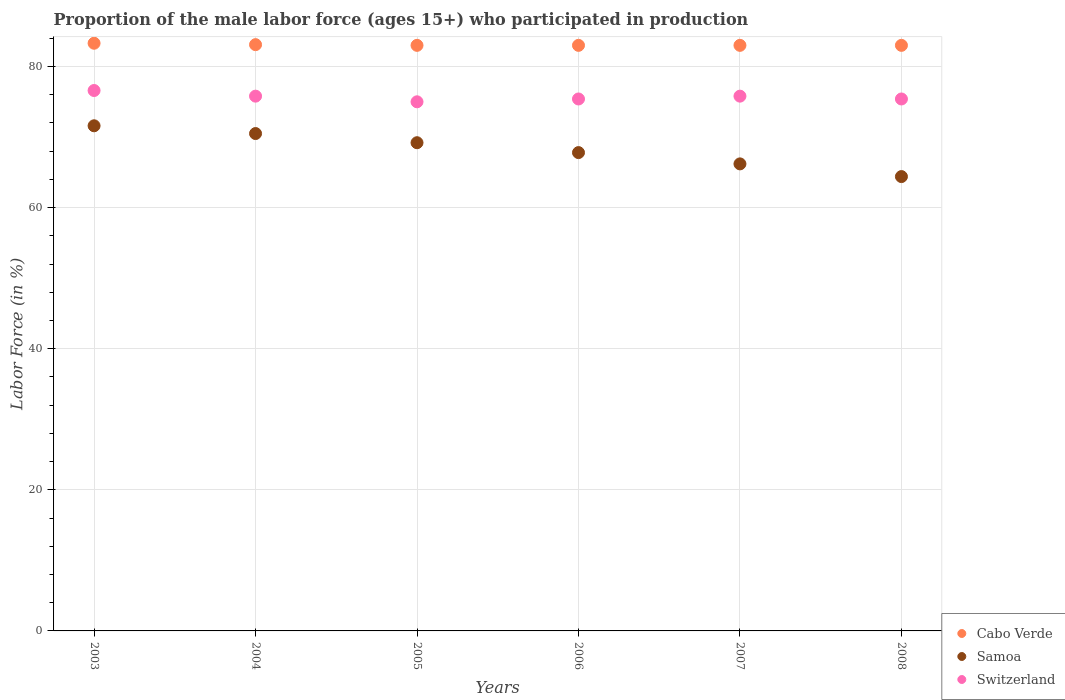How many different coloured dotlines are there?
Offer a terse response. 3. What is the proportion of the male labor force who participated in production in Samoa in 2004?
Your answer should be very brief. 70.5. Across all years, what is the maximum proportion of the male labor force who participated in production in Samoa?
Provide a short and direct response. 71.6. Across all years, what is the minimum proportion of the male labor force who participated in production in Samoa?
Keep it short and to the point. 64.4. In which year was the proportion of the male labor force who participated in production in Switzerland maximum?
Make the answer very short. 2003. In which year was the proportion of the male labor force who participated in production in Cabo Verde minimum?
Your answer should be compact. 2005. What is the total proportion of the male labor force who participated in production in Switzerland in the graph?
Provide a succinct answer. 454. What is the difference between the proportion of the male labor force who participated in production in Switzerland in 2004 and that in 2005?
Keep it short and to the point. 0.8. What is the difference between the proportion of the male labor force who participated in production in Cabo Verde in 2004 and the proportion of the male labor force who participated in production in Switzerland in 2007?
Provide a succinct answer. 7.3. What is the average proportion of the male labor force who participated in production in Samoa per year?
Give a very brief answer. 68.28. In the year 2004, what is the difference between the proportion of the male labor force who participated in production in Switzerland and proportion of the male labor force who participated in production in Cabo Verde?
Keep it short and to the point. -7.3. Is the difference between the proportion of the male labor force who participated in production in Switzerland in 2003 and 2006 greater than the difference between the proportion of the male labor force who participated in production in Cabo Verde in 2003 and 2006?
Make the answer very short. Yes. What is the difference between the highest and the second highest proportion of the male labor force who participated in production in Samoa?
Your answer should be very brief. 1.1. What is the difference between the highest and the lowest proportion of the male labor force who participated in production in Switzerland?
Keep it short and to the point. 1.6. Is the proportion of the male labor force who participated in production in Cabo Verde strictly greater than the proportion of the male labor force who participated in production in Samoa over the years?
Give a very brief answer. Yes. Is the proportion of the male labor force who participated in production in Switzerland strictly less than the proportion of the male labor force who participated in production in Cabo Verde over the years?
Provide a succinct answer. Yes. How many years are there in the graph?
Offer a terse response. 6. What is the difference between two consecutive major ticks on the Y-axis?
Offer a very short reply. 20. Does the graph contain any zero values?
Provide a succinct answer. No. Where does the legend appear in the graph?
Ensure brevity in your answer.  Bottom right. How many legend labels are there?
Give a very brief answer. 3. How are the legend labels stacked?
Give a very brief answer. Vertical. What is the title of the graph?
Offer a terse response. Proportion of the male labor force (ages 15+) who participated in production. Does "Palau" appear as one of the legend labels in the graph?
Make the answer very short. No. What is the label or title of the X-axis?
Make the answer very short. Years. What is the label or title of the Y-axis?
Give a very brief answer. Labor Force (in %). What is the Labor Force (in %) in Cabo Verde in 2003?
Your answer should be compact. 83.3. What is the Labor Force (in %) of Samoa in 2003?
Make the answer very short. 71.6. What is the Labor Force (in %) of Switzerland in 2003?
Make the answer very short. 76.6. What is the Labor Force (in %) in Cabo Verde in 2004?
Ensure brevity in your answer.  83.1. What is the Labor Force (in %) in Samoa in 2004?
Your answer should be compact. 70.5. What is the Labor Force (in %) in Switzerland in 2004?
Provide a succinct answer. 75.8. What is the Labor Force (in %) in Cabo Verde in 2005?
Provide a short and direct response. 83. What is the Labor Force (in %) of Samoa in 2005?
Your response must be concise. 69.2. What is the Labor Force (in %) of Samoa in 2006?
Your response must be concise. 67.8. What is the Labor Force (in %) in Switzerland in 2006?
Keep it short and to the point. 75.4. What is the Labor Force (in %) of Samoa in 2007?
Offer a terse response. 66.2. What is the Labor Force (in %) of Switzerland in 2007?
Offer a very short reply. 75.8. What is the Labor Force (in %) of Samoa in 2008?
Provide a succinct answer. 64.4. What is the Labor Force (in %) in Switzerland in 2008?
Give a very brief answer. 75.4. Across all years, what is the maximum Labor Force (in %) of Cabo Verde?
Your answer should be very brief. 83.3. Across all years, what is the maximum Labor Force (in %) of Samoa?
Make the answer very short. 71.6. Across all years, what is the maximum Labor Force (in %) of Switzerland?
Your response must be concise. 76.6. Across all years, what is the minimum Labor Force (in %) of Cabo Verde?
Your response must be concise. 83. Across all years, what is the minimum Labor Force (in %) of Samoa?
Give a very brief answer. 64.4. What is the total Labor Force (in %) of Cabo Verde in the graph?
Your answer should be compact. 498.4. What is the total Labor Force (in %) of Samoa in the graph?
Provide a succinct answer. 409.7. What is the total Labor Force (in %) in Switzerland in the graph?
Your answer should be very brief. 454. What is the difference between the Labor Force (in %) of Samoa in 2003 and that in 2004?
Make the answer very short. 1.1. What is the difference between the Labor Force (in %) of Switzerland in 2003 and that in 2004?
Your response must be concise. 0.8. What is the difference between the Labor Force (in %) of Cabo Verde in 2003 and that in 2006?
Offer a very short reply. 0.3. What is the difference between the Labor Force (in %) in Samoa in 2003 and that in 2006?
Your answer should be very brief. 3.8. What is the difference between the Labor Force (in %) in Switzerland in 2003 and that in 2007?
Your response must be concise. 0.8. What is the difference between the Labor Force (in %) in Cabo Verde in 2003 and that in 2008?
Provide a short and direct response. 0.3. What is the difference between the Labor Force (in %) of Switzerland in 2003 and that in 2008?
Provide a short and direct response. 1.2. What is the difference between the Labor Force (in %) in Cabo Verde in 2004 and that in 2005?
Your answer should be very brief. 0.1. What is the difference between the Labor Force (in %) of Samoa in 2004 and that in 2005?
Ensure brevity in your answer.  1.3. What is the difference between the Labor Force (in %) in Samoa in 2004 and that in 2006?
Give a very brief answer. 2.7. What is the difference between the Labor Force (in %) in Cabo Verde in 2004 and that in 2007?
Give a very brief answer. 0.1. What is the difference between the Labor Force (in %) in Switzerland in 2005 and that in 2006?
Give a very brief answer. -0.4. What is the difference between the Labor Force (in %) of Switzerland in 2005 and that in 2007?
Provide a short and direct response. -0.8. What is the difference between the Labor Force (in %) in Cabo Verde in 2005 and that in 2008?
Your answer should be compact. 0. What is the difference between the Labor Force (in %) of Samoa in 2005 and that in 2008?
Ensure brevity in your answer.  4.8. What is the difference between the Labor Force (in %) in Cabo Verde in 2006 and that in 2007?
Keep it short and to the point. 0. What is the difference between the Labor Force (in %) of Samoa in 2006 and that in 2007?
Provide a succinct answer. 1.6. What is the difference between the Labor Force (in %) of Switzerland in 2006 and that in 2007?
Ensure brevity in your answer.  -0.4. What is the difference between the Labor Force (in %) in Cabo Verde in 2006 and that in 2008?
Offer a terse response. 0. What is the difference between the Labor Force (in %) in Samoa in 2007 and that in 2008?
Your answer should be very brief. 1.8. What is the difference between the Labor Force (in %) in Switzerland in 2007 and that in 2008?
Offer a terse response. 0.4. What is the difference between the Labor Force (in %) of Cabo Verde in 2003 and the Labor Force (in %) of Samoa in 2004?
Keep it short and to the point. 12.8. What is the difference between the Labor Force (in %) of Cabo Verde in 2003 and the Labor Force (in %) of Switzerland in 2004?
Offer a terse response. 7.5. What is the difference between the Labor Force (in %) in Samoa in 2003 and the Labor Force (in %) in Switzerland in 2004?
Keep it short and to the point. -4.2. What is the difference between the Labor Force (in %) of Cabo Verde in 2003 and the Labor Force (in %) of Samoa in 2005?
Keep it short and to the point. 14.1. What is the difference between the Labor Force (in %) in Cabo Verde in 2003 and the Labor Force (in %) in Switzerland in 2005?
Ensure brevity in your answer.  8.3. What is the difference between the Labor Force (in %) of Cabo Verde in 2003 and the Labor Force (in %) of Samoa in 2006?
Your answer should be very brief. 15.5. What is the difference between the Labor Force (in %) of Cabo Verde in 2003 and the Labor Force (in %) of Samoa in 2007?
Offer a very short reply. 17.1. What is the difference between the Labor Force (in %) of Cabo Verde in 2003 and the Labor Force (in %) of Switzerland in 2008?
Your answer should be very brief. 7.9. What is the difference between the Labor Force (in %) of Cabo Verde in 2004 and the Labor Force (in %) of Samoa in 2005?
Ensure brevity in your answer.  13.9. What is the difference between the Labor Force (in %) in Cabo Verde in 2004 and the Labor Force (in %) in Switzerland in 2005?
Give a very brief answer. 8.1. What is the difference between the Labor Force (in %) of Cabo Verde in 2004 and the Labor Force (in %) of Samoa in 2006?
Your answer should be very brief. 15.3. What is the difference between the Labor Force (in %) in Cabo Verde in 2004 and the Labor Force (in %) in Switzerland in 2006?
Make the answer very short. 7.7. What is the difference between the Labor Force (in %) of Cabo Verde in 2004 and the Labor Force (in %) of Samoa in 2008?
Your answer should be compact. 18.7. What is the difference between the Labor Force (in %) in Cabo Verde in 2005 and the Labor Force (in %) in Switzerland in 2006?
Offer a terse response. 7.6. What is the difference between the Labor Force (in %) in Samoa in 2005 and the Labor Force (in %) in Switzerland in 2006?
Give a very brief answer. -6.2. What is the difference between the Labor Force (in %) of Cabo Verde in 2005 and the Labor Force (in %) of Samoa in 2007?
Provide a short and direct response. 16.8. What is the difference between the Labor Force (in %) in Cabo Verde in 2005 and the Labor Force (in %) in Switzerland in 2007?
Provide a short and direct response. 7.2. What is the difference between the Labor Force (in %) in Cabo Verde in 2005 and the Labor Force (in %) in Switzerland in 2008?
Your response must be concise. 7.6. What is the difference between the Labor Force (in %) of Samoa in 2005 and the Labor Force (in %) of Switzerland in 2008?
Provide a short and direct response. -6.2. What is the difference between the Labor Force (in %) in Cabo Verde in 2006 and the Labor Force (in %) in Samoa in 2007?
Make the answer very short. 16.8. What is the difference between the Labor Force (in %) of Cabo Verde in 2006 and the Labor Force (in %) of Switzerland in 2007?
Give a very brief answer. 7.2. What is the difference between the Labor Force (in %) in Cabo Verde in 2006 and the Labor Force (in %) in Samoa in 2008?
Ensure brevity in your answer.  18.6. What is the difference between the Labor Force (in %) in Samoa in 2006 and the Labor Force (in %) in Switzerland in 2008?
Offer a terse response. -7.6. What is the difference between the Labor Force (in %) in Cabo Verde in 2007 and the Labor Force (in %) in Samoa in 2008?
Make the answer very short. 18.6. What is the difference between the Labor Force (in %) in Cabo Verde in 2007 and the Labor Force (in %) in Switzerland in 2008?
Make the answer very short. 7.6. What is the average Labor Force (in %) in Cabo Verde per year?
Provide a succinct answer. 83.07. What is the average Labor Force (in %) in Samoa per year?
Your answer should be compact. 68.28. What is the average Labor Force (in %) of Switzerland per year?
Your answer should be compact. 75.67. In the year 2003, what is the difference between the Labor Force (in %) in Cabo Verde and Labor Force (in %) in Samoa?
Provide a short and direct response. 11.7. In the year 2003, what is the difference between the Labor Force (in %) in Cabo Verde and Labor Force (in %) in Switzerland?
Your response must be concise. 6.7. In the year 2004, what is the difference between the Labor Force (in %) of Cabo Verde and Labor Force (in %) of Samoa?
Offer a terse response. 12.6. In the year 2004, what is the difference between the Labor Force (in %) in Cabo Verde and Labor Force (in %) in Switzerland?
Your response must be concise. 7.3. In the year 2004, what is the difference between the Labor Force (in %) in Samoa and Labor Force (in %) in Switzerland?
Offer a very short reply. -5.3. In the year 2006, what is the difference between the Labor Force (in %) in Samoa and Labor Force (in %) in Switzerland?
Offer a very short reply. -7.6. In the year 2007, what is the difference between the Labor Force (in %) of Samoa and Labor Force (in %) of Switzerland?
Offer a terse response. -9.6. What is the ratio of the Labor Force (in %) of Samoa in 2003 to that in 2004?
Your answer should be compact. 1.02. What is the ratio of the Labor Force (in %) in Switzerland in 2003 to that in 2004?
Provide a short and direct response. 1.01. What is the ratio of the Labor Force (in %) in Samoa in 2003 to that in 2005?
Offer a terse response. 1.03. What is the ratio of the Labor Force (in %) of Switzerland in 2003 to that in 2005?
Offer a very short reply. 1.02. What is the ratio of the Labor Force (in %) of Cabo Verde in 2003 to that in 2006?
Your response must be concise. 1. What is the ratio of the Labor Force (in %) of Samoa in 2003 to that in 2006?
Keep it short and to the point. 1.06. What is the ratio of the Labor Force (in %) of Switzerland in 2003 to that in 2006?
Ensure brevity in your answer.  1.02. What is the ratio of the Labor Force (in %) in Samoa in 2003 to that in 2007?
Your response must be concise. 1.08. What is the ratio of the Labor Force (in %) in Switzerland in 2003 to that in 2007?
Make the answer very short. 1.01. What is the ratio of the Labor Force (in %) of Cabo Verde in 2003 to that in 2008?
Your answer should be very brief. 1. What is the ratio of the Labor Force (in %) in Samoa in 2003 to that in 2008?
Keep it short and to the point. 1.11. What is the ratio of the Labor Force (in %) in Switzerland in 2003 to that in 2008?
Provide a short and direct response. 1.02. What is the ratio of the Labor Force (in %) in Cabo Verde in 2004 to that in 2005?
Keep it short and to the point. 1. What is the ratio of the Labor Force (in %) in Samoa in 2004 to that in 2005?
Keep it short and to the point. 1.02. What is the ratio of the Labor Force (in %) of Switzerland in 2004 to that in 2005?
Provide a succinct answer. 1.01. What is the ratio of the Labor Force (in %) in Cabo Verde in 2004 to that in 2006?
Provide a short and direct response. 1. What is the ratio of the Labor Force (in %) in Samoa in 2004 to that in 2006?
Provide a short and direct response. 1.04. What is the ratio of the Labor Force (in %) in Cabo Verde in 2004 to that in 2007?
Provide a succinct answer. 1. What is the ratio of the Labor Force (in %) of Samoa in 2004 to that in 2007?
Make the answer very short. 1.06. What is the ratio of the Labor Force (in %) in Samoa in 2004 to that in 2008?
Make the answer very short. 1.09. What is the ratio of the Labor Force (in %) of Samoa in 2005 to that in 2006?
Provide a succinct answer. 1.02. What is the ratio of the Labor Force (in %) in Switzerland in 2005 to that in 2006?
Your answer should be compact. 0.99. What is the ratio of the Labor Force (in %) in Samoa in 2005 to that in 2007?
Your response must be concise. 1.05. What is the ratio of the Labor Force (in %) in Samoa in 2005 to that in 2008?
Offer a terse response. 1.07. What is the ratio of the Labor Force (in %) in Switzerland in 2005 to that in 2008?
Your response must be concise. 0.99. What is the ratio of the Labor Force (in %) in Samoa in 2006 to that in 2007?
Offer a terse response. 1.02. What is the ratio of the Labor Force (in %) of Switzerland in 2006 to that in 2007?
Ensure brevity in your answer.  0.99. What is the ratio of the Labor Force (in %) in Cabo Verde in 2006 to that in 2008?
Offer a very short reply. 1. What is the ratio of the Labor Force (in %) of Samoa in 2006 to that in 2008?
Your answer should be very brief. 1.05. What is the ratio of the Labor Force (in %) in Switzerland in 2006 to that in 2008?
Provide a succinct answer. 1. What is the ratio of the Labor Force (in %) in Cabo Verde in 2007 to that in 2008?
Offer a very short reply. 1. What is the ratio of the Labor Force (in %) of Samoa in 2007 to that in 2008?
Provide a succinct answer. 1.03. What is the difference between the highest and the second highest Labor Force (in %) in Cabo Verde?
Your answer should be compact. 0.2. What is the difference between the highest and the lowest Labor Force (in %) in Samoa?
Keep it short and to the point. 7.2. What is the difference between the highest and the lowest Labor Force (in %) of Switzerland?
Make the answer very short. 1.6. 